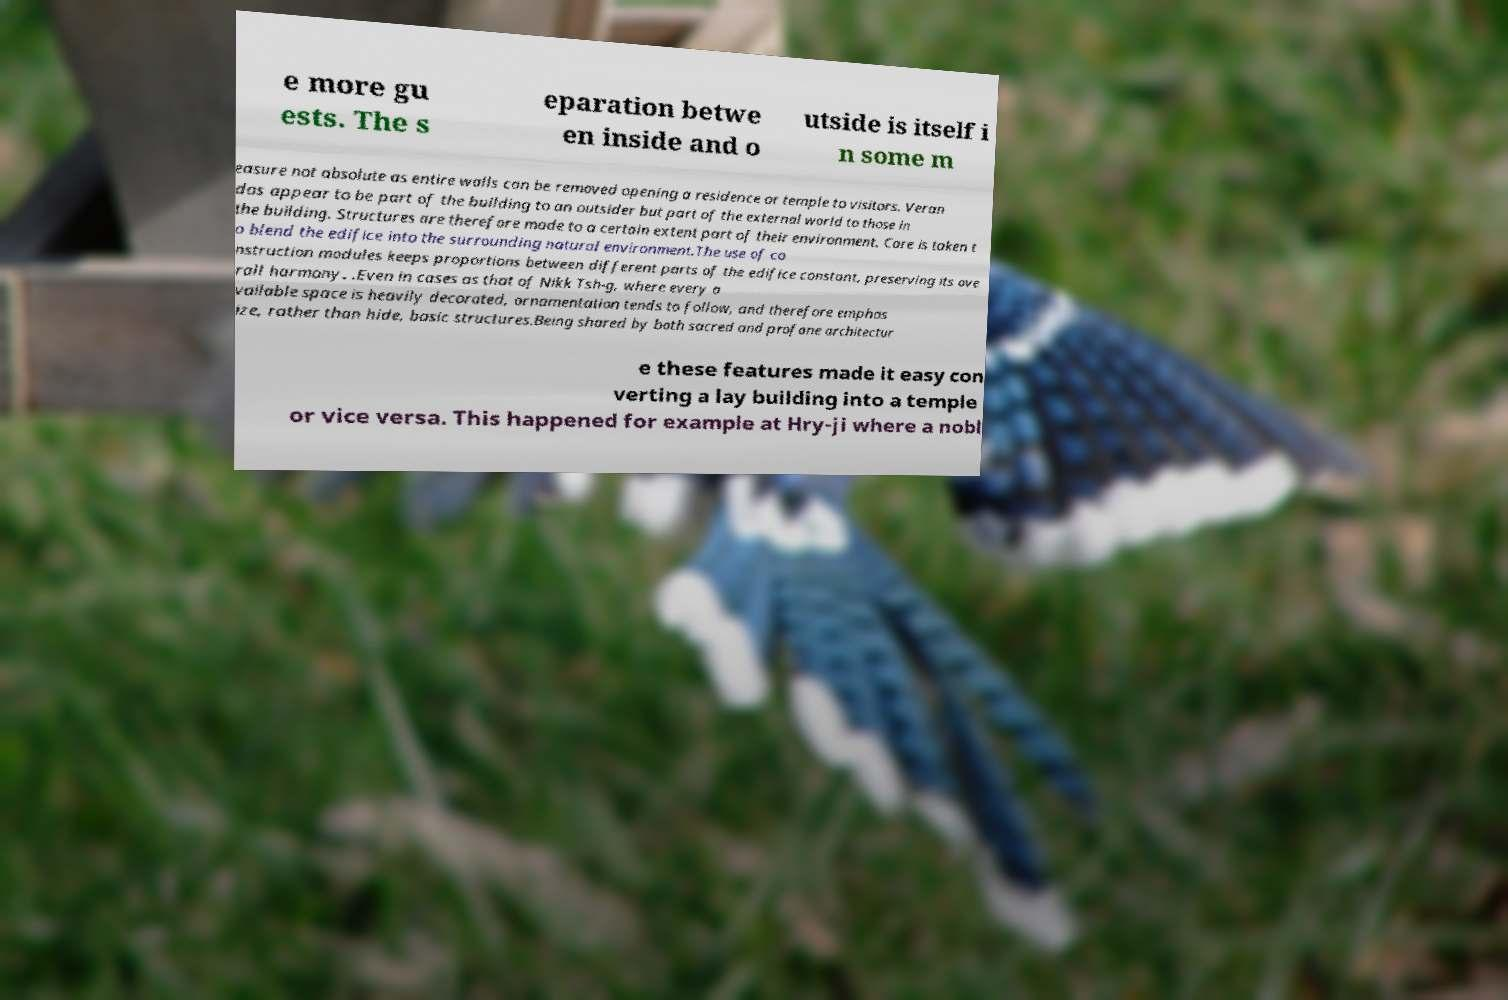What messages or text are displayed in this image? I need them in a readable, typed format. e more gu ests. The s eparation betwe en inside and o utside is itself i n some m easure not absolute as entire walls can be removed opening a residence or temple to visitors. Veran das appear to be part of the building to an outsider but part of the external world to those in the building. Structures are therefore made to a certain extent part of their environment. Care is taken t o blend the edifice into the surrounding natural environment.The use of co nstruction modules keeps proportions between different parts of the edifice constant, preserving its ove rall harmony. .Even in cases as that of Nikk Tsh-g, where every a vailable space is heavily decorated, ornamentation tends to follow, and therefore emphas ize, rather than hide, basic structures.Being shared by both sacred and profane architectur e these features made it easy con verting a lay building into a temple or vice versa. This happened for example at Hry-ji where a nobl 